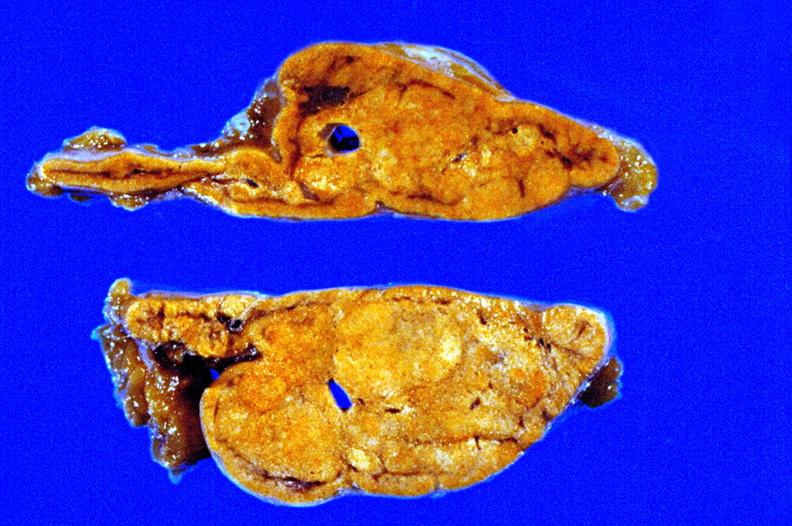what is present?
Answer the question using a single word or phrase. Nodules 